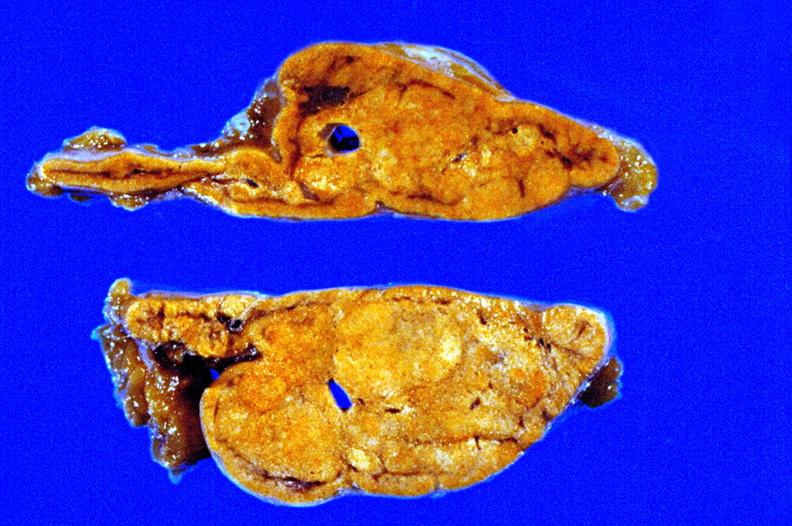what is present?
Answer the question using a single word or phrase. Nodules 